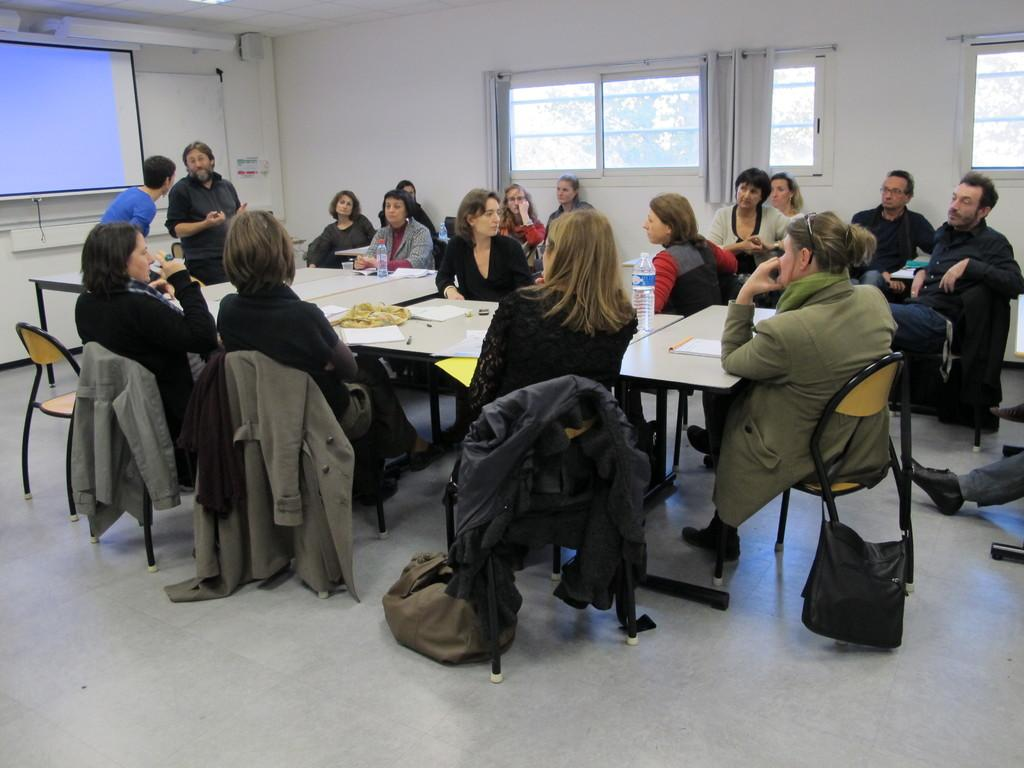What is happening in the image involving a group of people? There is a group of people in the image, and they are sitting and discussing. Are there any other people in the image besides the group? Yes, there are two people standing nearby. What are the two standing people doing? The two standing people are talking to each other. What type of frame surrounds the group of people in the image? There is no frame surrounding the group of people in the image. What is the hope of the people in the image? The provided facts do not give any information about the hopes or intentions of the people in the image. 